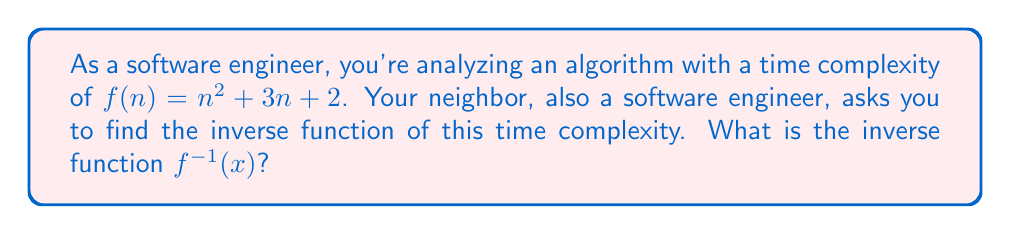Show me your answer to this math problem. To find the inverse function, we'll follow these steps:

1) First, replace $f(n)$ with $y$:
   $y = n^2 + 3n + 2$

2) Swap $y$ and $n$:
   $x = y^2 + 3y + 2$

3) Now, we need to solve for $y$ in terms of $x$. This is a quadratic equation, so we'll use the quadratic formula:
   $y^2 + 3y + (2-x) = 0$

4) Apply the quadratic formula: $y = \frac{-b \pm \sqrt{b^2 - 4ac}}{2a}$
   Where $a=1$, $b=3$, and $c=(2-x)$

5) Substituting these values:
   $y = \frac{-3 \pm \sqrt{3^2 - 4(1)(2-x)}}{2(1)}$

6) Simplify:
   $y = \frac{-3 \pm \sqrt{9 - 4(2-x)}}{2} = \frac{-3 \pm \sqrt{9 - 8 + 4x}}{2} = \frac{-3 \pm \sqrt{4x + 1}}{2}$

7) Since we're dealing with time complexity, we're only interested in the positive root:
   $y = \frac{-3 + \sqrt{4x + 1}}{2}$

8) Replace $y$ with $f^{-1}(x)$ to get the final inverse function:
   $f^{-1}(x) = \frac{-3 + \sqrt{4x + 1}}{2}$
Answer: $f^{-1}(x) = \frac{-3 + \sqrt{4x + 1}}{2}$ 